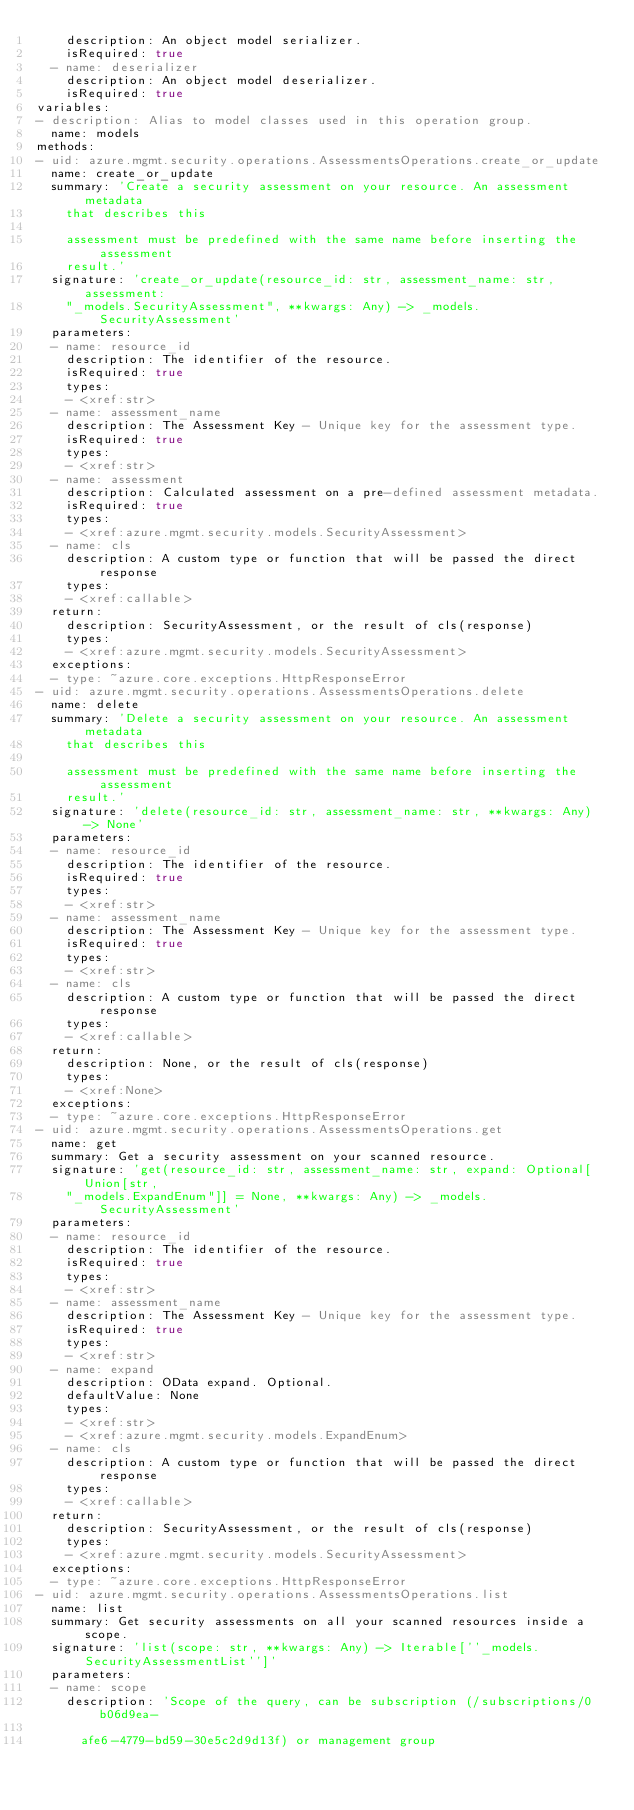<code> <loc_0><loc_0><loc_500><loc_500><_YAML_>    description: An object model serializer.
    isRequired: true
  - name: deserializer
    description: An object model deserializer.
    isRequired: true
variables:
- description: Alias to model classes used in this operation group.
  name: models
methods:
- uid: azure.mgmt.security.operations.AssessmentsOperations.create_or_update
  name: create_or_update
  summary: 'Create a security assessment on your resource. An assessment metadata
    that describes this

    assessment must be predefined with the same name before inserting the assessment
    result.'
  signature: 'create_or_update(resource_id: str, assessment_name: str, assessment:
    "_models.SecurityAssessment", **kwargs: Any) -> _models.SecurityAssessment'
  parameters:
  - name: resource_id
    description: The identifier of the resource.
    isRequired: true
    types:
    - <xref:str>
  - name: assessment_name
    description: The Assessment Key - Unique key for the assessment type.
    isRequired: true
    types:
    - <xref:str>
  - name: assessment
    description: Calculated assessment on a pre-defined assessment metadata.
    isRequired: true
    types:
    - <xref:azure.mgmt.security.models.SecurityAssessment>
  - name: cls
    description: A custom type or function that will be passed the direct response
    types:
    - <xref:callable>
  return:
    description: SecurityAssessment, or the result of cls(response)
    types:
    - <xref:azure.mgmt.security.models.SecurityAssessment>
  exceptions:
  - type: ~azure.core.exceptions.HttpResponseError
- uid: azure.mgmt.security.operations.AssessmentsOperations.delete
  name: delete
  summary: 'Delete a security assessment on your resource. An assessment metadata
    that describes this

    assessment must be predefined with the same name before inserting the assessment
    result.'
  signature: 'delete(resource_id: str, assessment_name: str, **kwargs: Any) -> None'
  parameters:
  - name: resource_id
    description: The identifier of the resource.
    isRequired: true
    types:
    - <xref:str>
  - name: assessment_name
    description: The Assessment Key - Unique key for the assessment type.
    isRequired: true
    types:
    - <xref:str>
  - name: cls
    description: A custom type or function that will be passed the direct response
    types:
    - <xref:callable>
  return:
    description: None, or the result of cls(response)
    types:
    - <xref:None>
  exceptions:
  - type: ~azure.core.exceptions.HttpResponseError
- uid: azure.mgmt.security.operations.AssessmentsOperations.get
  name: get
  summary: Get a security assessment on your scanned resource.
  signature: 'get(resource_id: str, assessment_name: str, expand: Optional[Union[str,
    "_models.ExpandEnum"]] = None, **kwargs: Any) -> _models.SecurityAssessment'
  parameters:
  - name: resource_id
    description: The identifier of the resource.
    isRequired: true
    types:
    - <xref:str>
  - name: assessment_name
    description: The Assessment Key - Unique key for the assessment type.
    isRequired: true
    types:
    - <xref:str>
  - name: expand
    description: OData expand. Optional.
    defaultValue: None
    types:
    - <xref:str>
    - <xref:azure.mgmt.security.models.ExpandEnum>
  - name: cls
    description: A custom type or function that will be passed the direct response
    types:
    - <xref:callable>
  return:
    description: SecurityAssessment, or the result of cls(response)
    types:
    - <xref:azure.mgmt.security.models.SecurityAssessment>
  exceptions:
  - type: ~azure.core.exceptions.HttpResponseError
- uid: azure.mgmt.security.operations.AssessmentsOperations.list
  name: list
  summary: Get security assessments on all your scanned resources inside a scope.
  signature: 'list(scope: str, **kwargs: Any) -> Iterable[''_models.SecurityAssessmentList'']'
  parameters:
  - name: scope
    description: 'Scope of the query, can be subscription (/subscriptions/0b06d9ea-

      afe6-4779-bd59-30e5c2d9d13f) or management group
</code> 